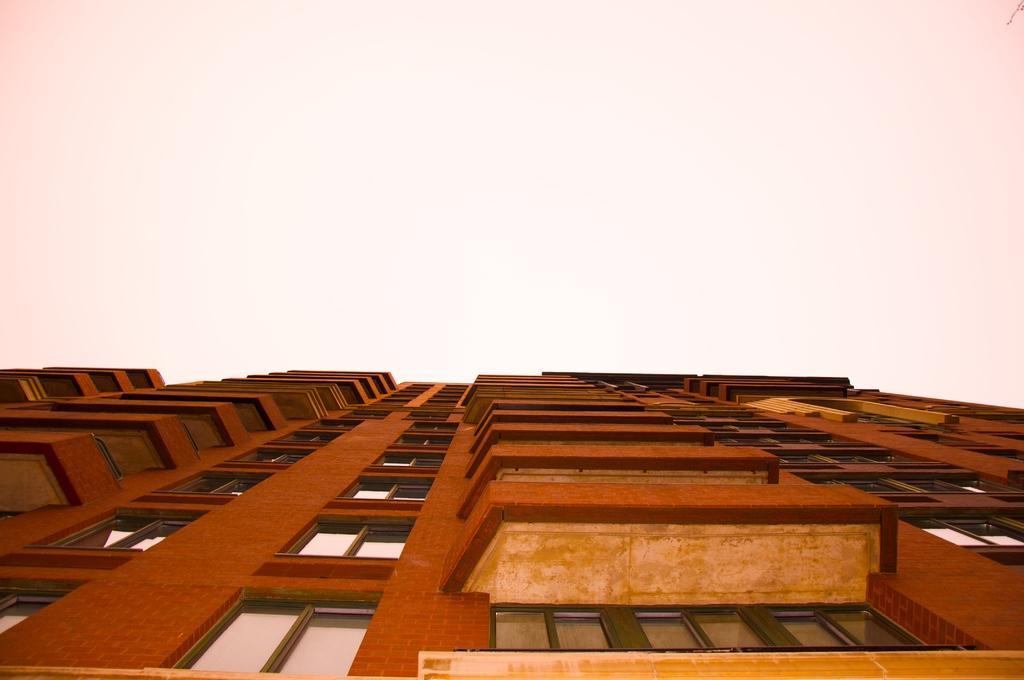Could you give a brief overview of what you see in this image? In the image we can see the building and these are the windows of the building and the sky. 